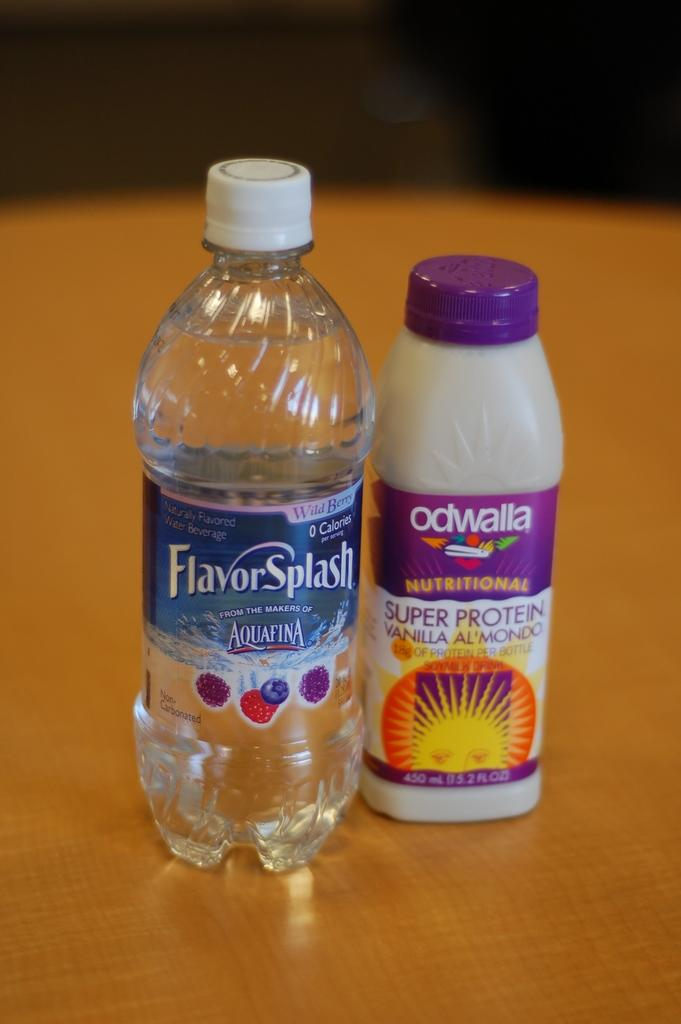<image>
Render a clear and concise summary of the photo. A bottle of Aquafina FlavorSplash water is next to a bottle of Odwalla smoothie 